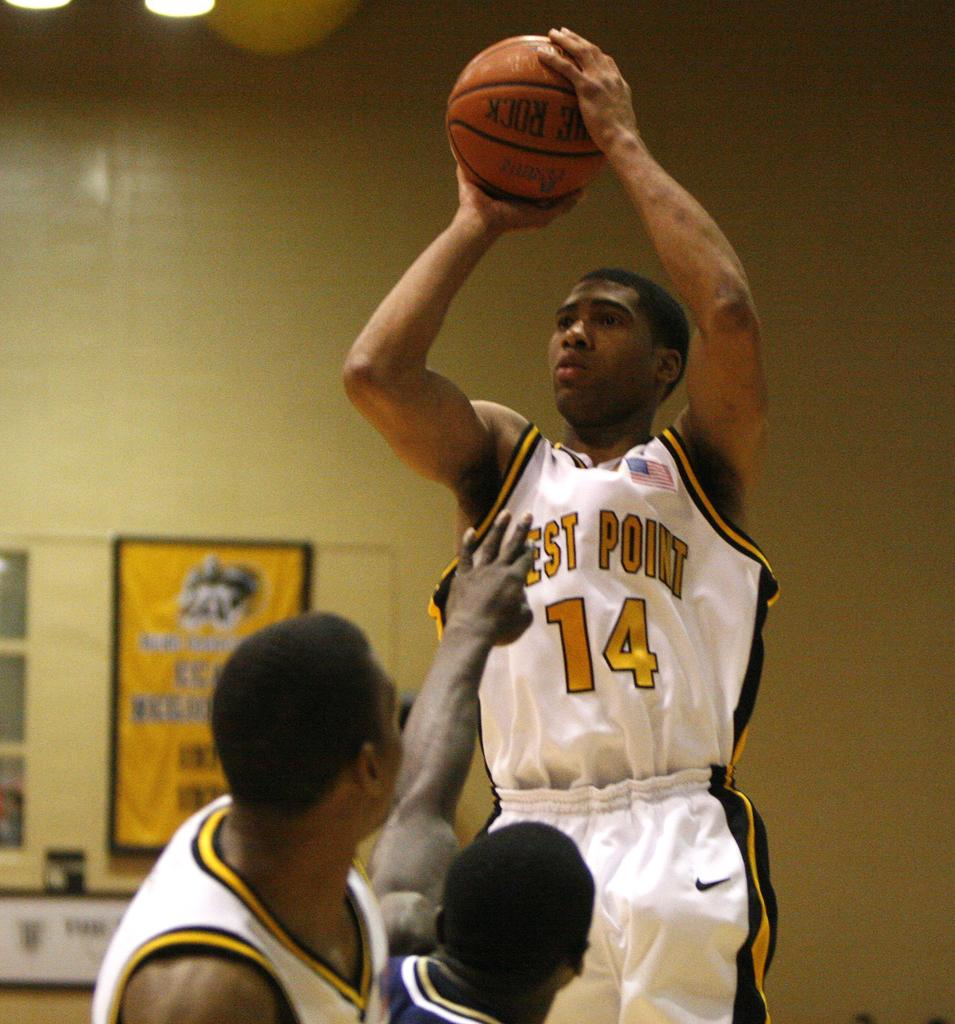Provide a one-sentence caption for the provided image. The player for West Point jumps up to shoot the basketball. 